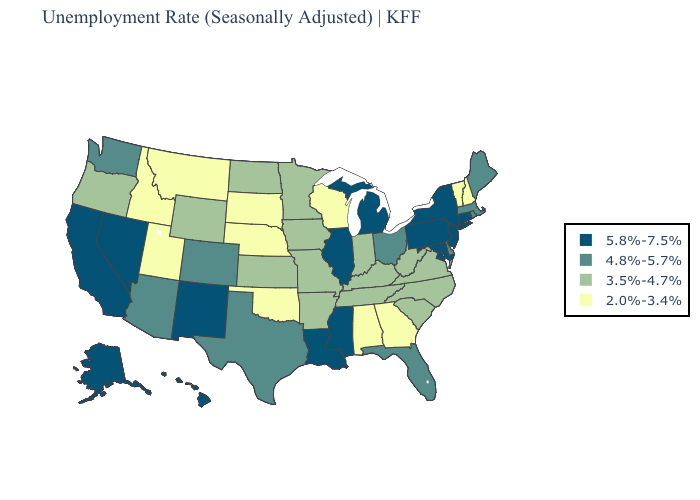What is the lowest value in the USA?
Quick response, please. 2.0%-3.4%. Name the states that have a value in the range 3.5%-4.7%?
Keep it brief. Arkansas, Indiana, Iowa, Kansas, Kentucky, Minnesota, Missouri, North Carolina, North Dakota, Oregon, South Carolina, Tennessee, Virginia, West Virginia, Wyoming. Name the states that have a value in the range 4.8%-5.7%?
Answer briefly. Arizona, Colorado, Delaware, Florida, Maine, Massachusetts, Ohio, Rhode Island, Texas, Washington. Name the states that have a value in the range 5.8%-7.5%?
Quick response, please. Alaska, California, Connecticut, Hawaii, Illinois, Louisiana, Maryland, Michigan, Mississippi, Nevada, New Jersey, New Mexico, New York, Pennsylvania. Does Illinois have the lowest value in the MidWest?
Be succinct. No. What is the value of Virginia?
Concise answer only. 3.5%-4.7%. Name the states that have a value in the range 2.0%-3.4%?
Concise answer only. Alabama, Georgia, Idaho, Montana, Nebraska, New Hampshire, Oklahoma, South Dakota, Utah, Vermont, Wisconsin. Among the states that border Wisconsin , does Illinois have the highest value?
Write a very short answer. Yes. Which states have the lowest value in the USA?
Write a very short answer. Alabama, Georgia, Idaho, Montana, Nebraska, New Hampshire, Oklahoma, South Dakota, Utah, Vermont, Wisconsin. Does Mississippi have a higher value than Rhode Island?
Be succinct. Yes. Name the states that have a value in the range 5.8%-7.5%?
Keep it brief. Alaska, California, Connecticut, Hawaii, Illinois, Louisiana, Maryland, Michigan, Mississippi, Nevada, New Jersey, New Mexico, New York, Pennsylvania. What is the value of Mississippi?
Answer briefly. 5.8%-7.5%. Which states hav the highest value in the Northeast?
Short answer required. Connecticut, New Jersey, New York, Pennsylvania. What is the value of Indiana?
Keep it brief. 3.5%-4.7%. Is the legend a continuous bar?
Quick response, please. No. 